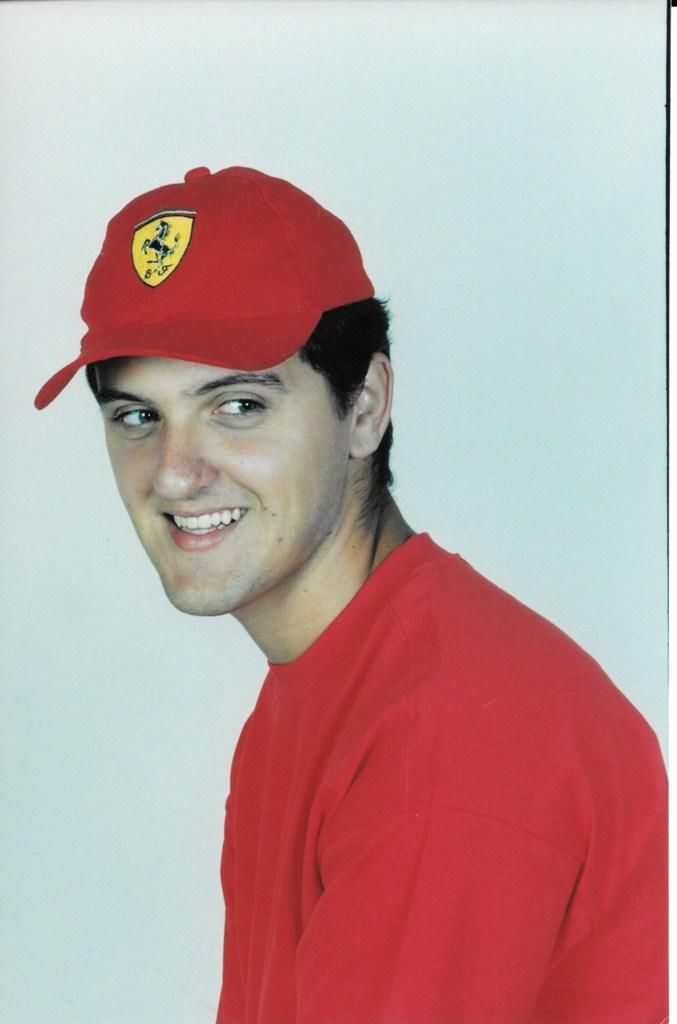Who or what is the main subject of the image? There is a person in the image. What is the person wearing on their upper body? The person is wearing a red t-shirt. What type of headwear is the person wearing? The person is wearing a red cap. What color is the background of the image? The background of the image is white. What type of crayon is the person holding in the image? There is no crayon present in the image. What song is the person singing in the image? There is no indication that the person is singing in the image. 